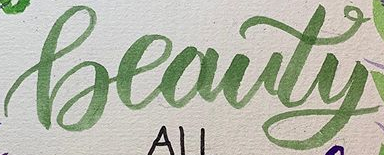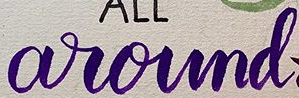Transcribe the words shown in these images in order, separated by a semicolon. Beauty; around 